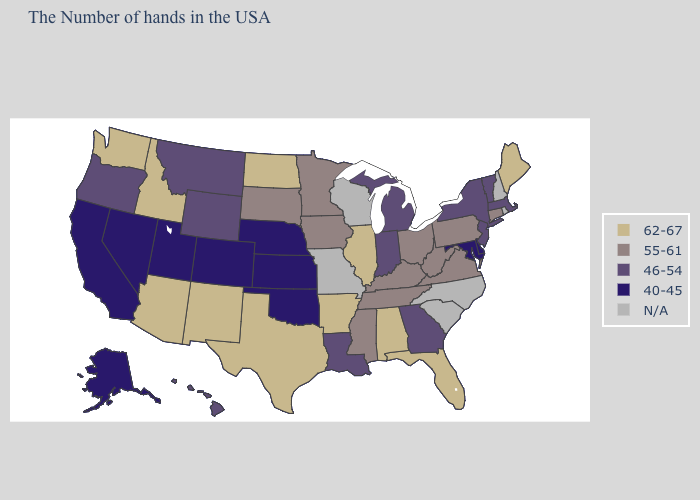Name the states that have a value in the range 40-45?
Be succinct. Delaware, Maryland, Kansas, Nebraska, Oklahoma, Colorado, Utah, Nevada, California, Alaska. What is the highest value in states that border Minnesota?
Be succinct. 62-67. What is the value of Texas?
Give a very brief answer. 62-67. Name the states that have a value in the range 62-67?
Keep it brief. Maine, Florida, Alabama, Illinois, Arkansas, Texas, North Dakota, New Mexico, Arizona, Idaho, Washington. How many symbols are there in the legend?
Keep it brief. 5. Name the states that have a value in the range N/A?
Keep it brief. Rhode Island, New Hampshire, North Carolina, South Carolina, Wisconsin, Missouri. Does the map have missing data?
Give a very brief answer. Yes. What is the value of Georgia?
Short answer required. 46-54. What is the lowest value in the MidWest?
Write a very short answer. 40-45. Name the states that have a value in the range 62-67?
Answer briefly. Maine, Florida, Alabama, Illinois, Arkansas, Texas, North Dakota, New Mexico, Arizona, Idaho, Washington. Which states have the highest value in the USA?
Write a very short answer. Maine, Florida, Alabama, Illinois, Arkansas, Texas, North Dakota, New Mexico, Arizona, Idaho, Washington. What is the lowest value in states that border Wyoming?
Short answer required. 40-45. Name the states that have a value in the range 62-67?
Answer briefly. Maine, Florida, Alabama, Illinois, Arkansas, Texas, North Dakota, New Mexico, Arizona, Idaho, Washington. What is the value of North Carolina?
Quick response, please. N/A. 